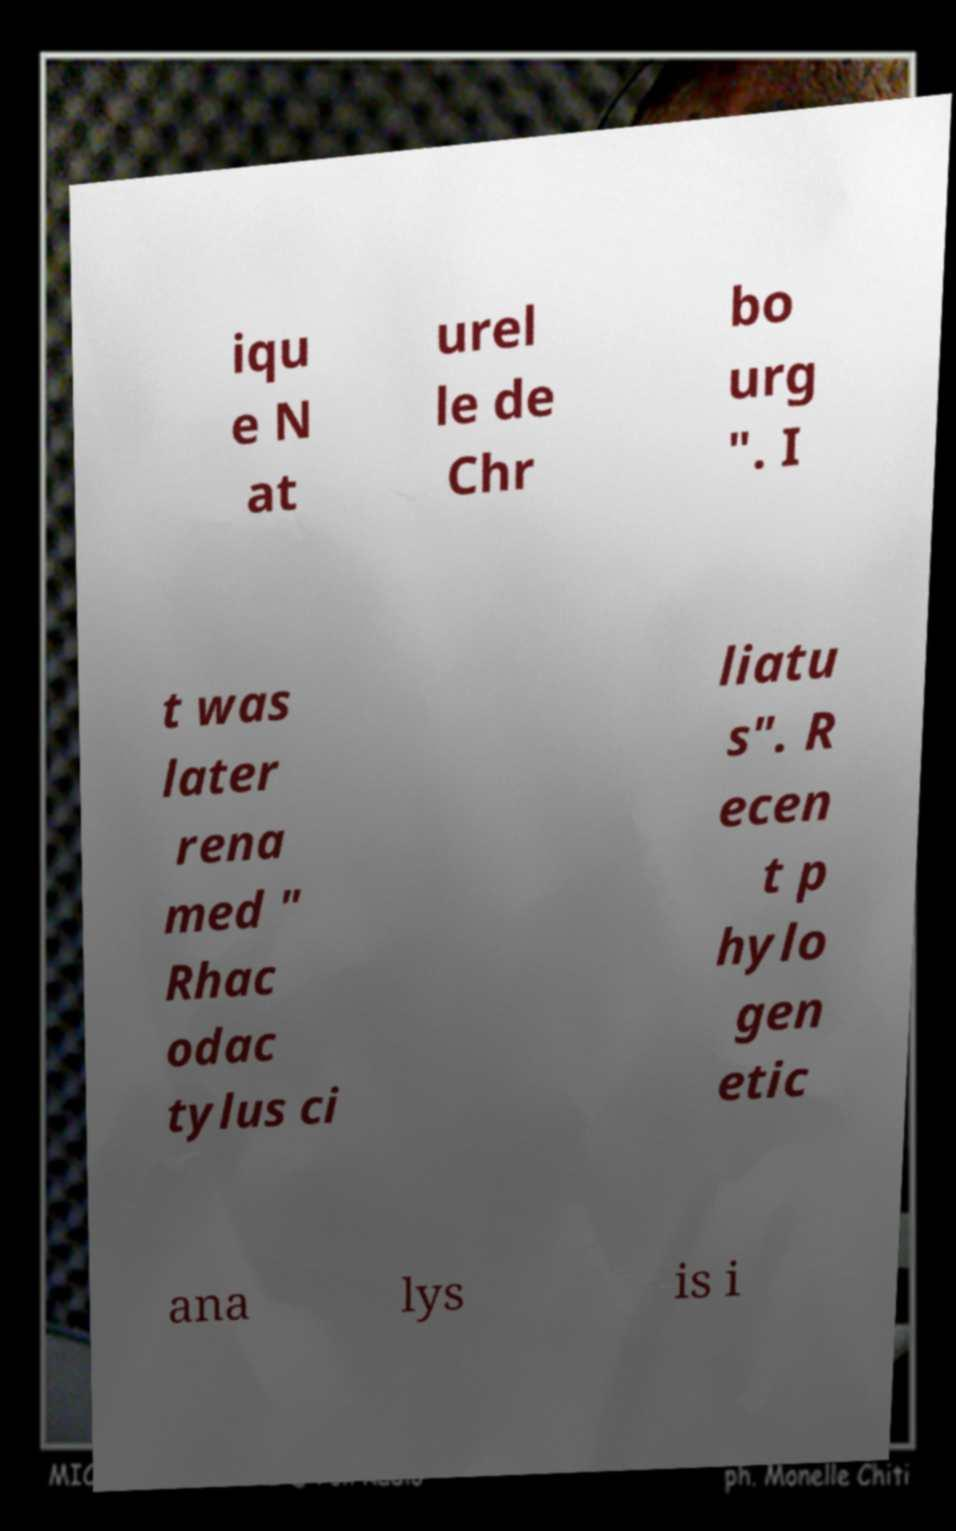Can you accurately transcribe the text from the provided image for me? iqu e N at urel le de Chr bo urg ". I t was later rena med " Rhac odac tylus ci liatu s". R ecen t p hylo gen etic ana lys is i 